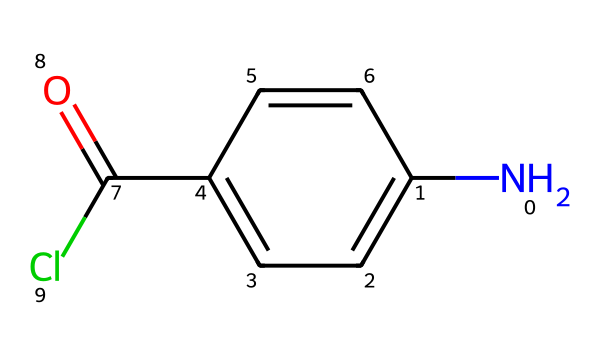What is the total number of carbon atoms in this chemical? By examining the structure represented in the SMILES notation, we can count the carbon atoms. In this case, there are six carbon atoms located in the aromatic ring (c1ccc(cc1)), and one additional carbon in the carbonyl (C(=O)), totaling seven.
Answer: seven How many nitrogen atoms are present in this structure? The SMILES notation shows one nitrogen atom (N) at the beginning. Therefore, there is exactly one nitrogen in this chemical.
Answer: one What type of functional group is present in this compound? The compound contains a carbonyl group (C=O) indicated by C(=O) and a chloro group (Cl). Thus, the presence of both indicates the compound has acyl chloride functionality.
Answer: acyl chloride What is the degree of saturation of the compound? The SMILES representation indicates that the compound contains a ring and various atoms, specifically two double bonds (one in the carbonyl and one in the aromatic structure). This suggests a total saturation count. Using the formula for determining saturation, we conclude that the structure shows one degree of saturation.
Answer: one What is the primary use of the monomer represented by this chemical? This monomer is involved in polymer production, specifically for creating Kevlar, which is widely used in protective gear due to its high tensile strength and durability.
Answer: protective gear What type of polymerization is likely employed for this monomer? The presence of the reactive acyl chloride suggests that condensation polymerization, where molecules combine and release a small molecule (like HCl) is a likely pathway for forming polymers from this monomer.
Answer: condensation polymerization 